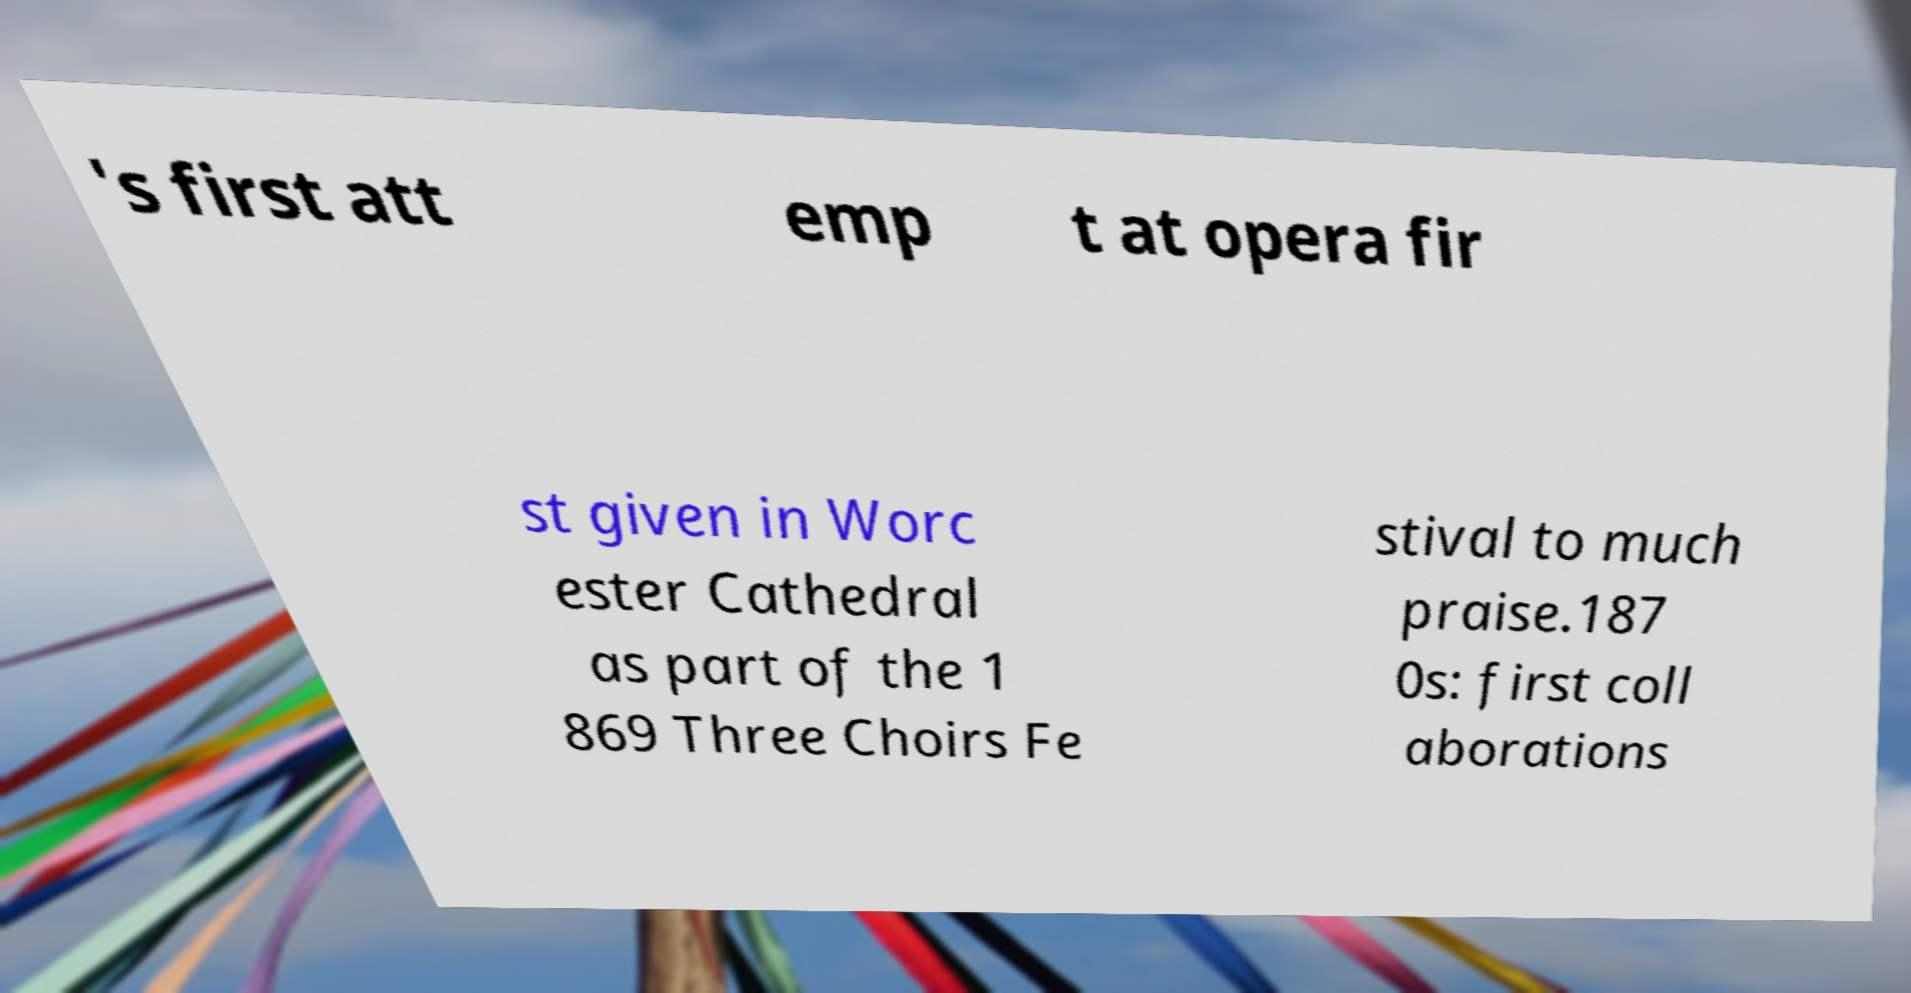For documentation purposes, I need the text within this image transcribed. Could you provide that? 's first att emp t at opera fir st given in Worc ester Cathedral as part of the 1 869 Three Choirs Fe stival to much praise.187 0s: first coll aborations 